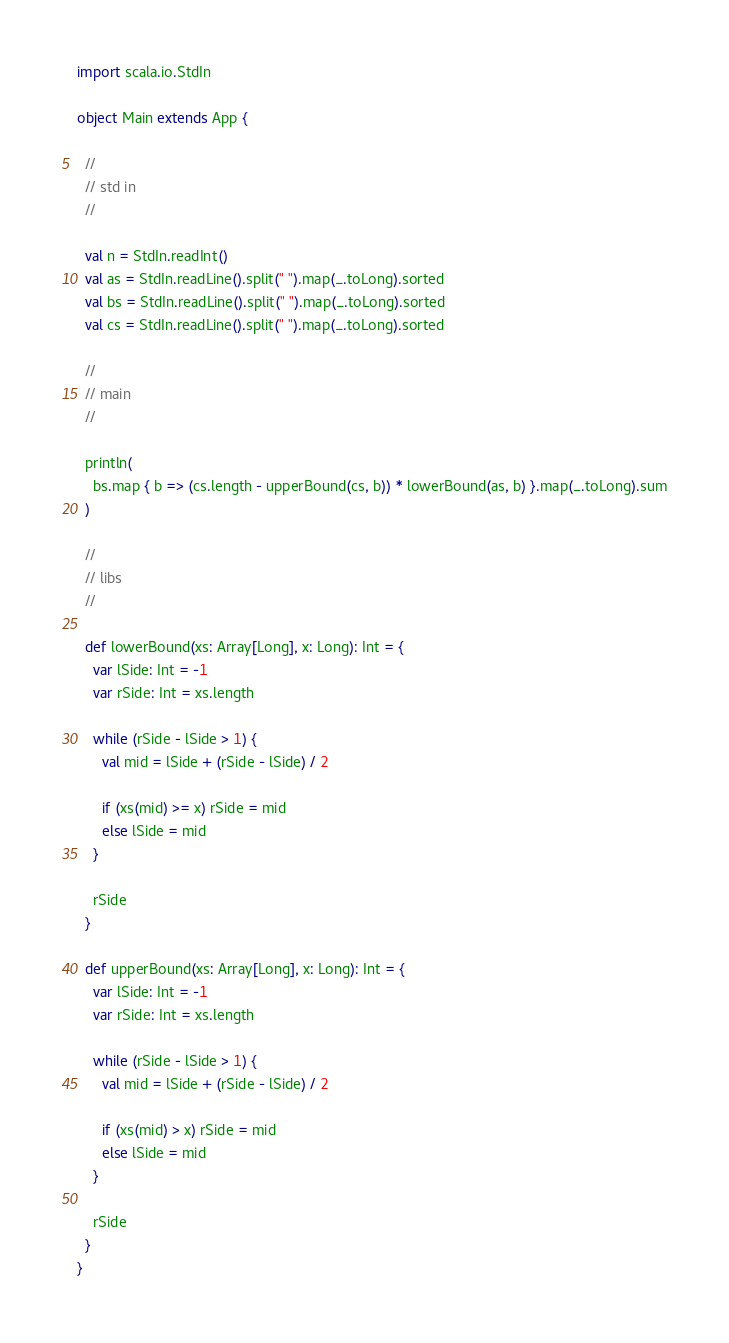<code> <loc_0><loc_0><loc_500><loc_500><_Scala_>import scala.io.StdIn

object Main extends App {

  //
  // std in
  //

  val n = StdIn.readInt()
  val as = StdIn.readLine().split(" ").map(_.toLong).sorted
  val bs = StdIn.readLine().split(" ").map(_.toLong).sorted
  val cs = StdIn.readLine().split(" ").map(_.toLong).sorted

  //
  // main
  //

  println(
    bs.map { b => (cs.length - upperBound(cs, b)) * lowerBound(as, b) }.map(_.toLong).sum
  )

  //
  // libs
  //

  def lowerBound(xs: Array[Long], x: Long): Int = {
    var lSide: Int = -1
    var rSide: Int = xs.length

    while (rSide - lSide > 1) {
      val mid = lSide + (rSide - lSide) / 2

      if (xs(mid) >= x) rSide = mid
      else lSide = mid
    }

    rSide
  }

  def upperBound(xs: Array[Long], x: Long): Int = {
    var lSide: Int = -1
    var rSide: Int = xs.length

    while (rSide - lSide > 1) {
      val mid = lSide + (rSide - lSide) / 2

      if (xs(mid) > x) rSide = mid
      else lSide = mid
    }

    rSide
  }
}
</code> 